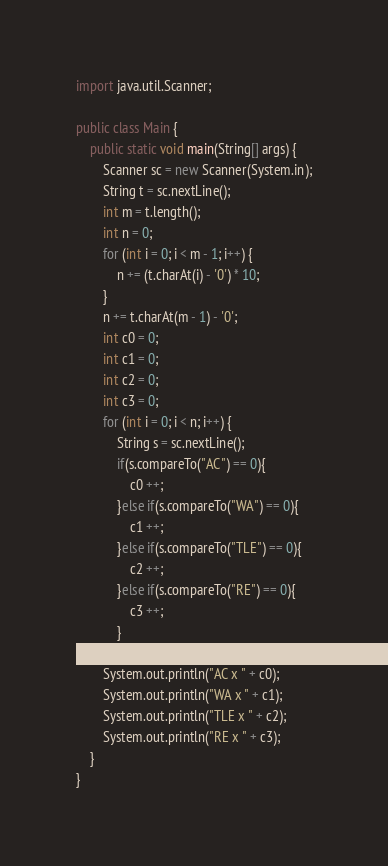<code> <loc_0><loc_0><loc_500><loc_500><_Java_>import java.util.Scanner;

public class Main {
    public static void main(String[] args) {
        Scanner sc = new Scanner(System.in);
        String t = sc.nextLine();
        int m = t.length();
        int n = 0;
        for (int i = 0; i < m - 1; i++) {
            n += (t.charAt(i) - '0') * 10;
        }
        n += t.charAt(m - 1) - '0';
        int c0 = 0;
        int c1 = 0;
        int c2 = 0;
        int c3 = 0;
        for (int i = 0; i < n; i++) {
            String s = sc.nextLine();
            if(s.compareTo("AC") == 0){
                c0 ++;
            }else if(s.compareTo("WA") == 0){
                c1 ++;
            }else if(s.compareTo("TLE") == 0){
                c2 ++;
            }else if(s.compareTo("RE") == 0){
                c3 ++;
            }
        }
        System.out.println("AC x " + c0);
        System.out.println("WA x " + c1);
        System.out.println("TLE x " + c2);
        System.out.println("RE x " + c3);
    }
}</code> 